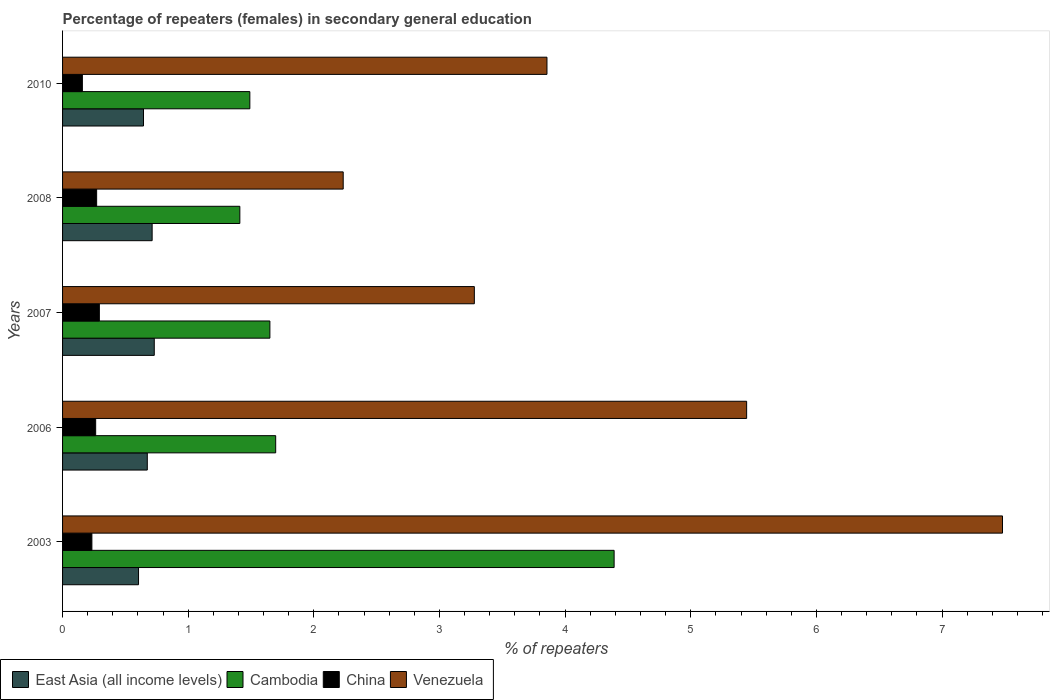How many groups of bars are there?
Offer a terse response. 5. How many bars are there on the 3rd tick from the bottom?
Your answer should be very brief. 4. What is the percentage of female repeaters in East Asia (all income levels) in 2007?
Keep it short and to the point. 0.73. Across all years, what is the maximum percentage of female repeaters in Cambodia?
Provide a short and direct response. 4.39. Across all years, what is the minimum percentage of female repeaters in China?
Give a very brief answer. 0.16. In which year was the percentage of female repeaters in China maximum?
Your answer should be compact. 2007. In which year was the percentage of female repeaters in East Asia (all income levels) minimum?
Provide a short and direct response. 2003. What is the total percentage of female repeaters in East Asia (all income levels) in the graph?
Ensure brevity in your answer.  3.37. What is the difference between the percentage of female repeaters in Cambodia in 2003 and that in 2006?
Provide a short and direct response. 2.69. What is the difference between the percentage of female repeaters in China in 2006 and the percentage of female repeaters in Cambodia in 2007?
Provide a short and direct response. -1.39. What is the average percentage of female repeaters in Venezuela per year?
Provide a short and direct response. 4.46. In the year 2007, what is the difference between the percentage of female repeaters in China and percentage of female repeaters in Cambodia?
Give a very brief answer. -1.36. In how many years, is the percentage of female repeaters in China greater than 7 %?
Keep it short and to the point. 0. What is the ratio of the percentage of female repeaters in Cambodia in 2003 to that in 2008?
Give a very brief answer. 3.11. Is the difference between the percentage of female repeaters in China in 2006 and 2007 greater than the difference between the percentage of female repeaters in Cambodia in 2006 and 2007?
Your response must be concise. No. What is the difference between the highest and the second highest percentage of female repeaters in East Asia (all income levels)?
Provide a succinct answer. 0.02. What is the difference between the highest and the lowest percentage of female repeaters in China?
Give a very brief answer. 0.14. In how many years, is the percentage of female repeaters in China greater than the average percentage of female repeaters in China taken over all years?
Ensure brevity in your answer.  3. Is the sum of the percentage of female repeaters in Venezuela in 2008 and 2010 greater than the maximum percentage of female repeaters in East Asia (all income levels) across all years?
Make the answer very short. Yes. What does the 1st bar from the top in 2003 represents?
Your answer should be very brief. Venezuela. What does the 1st bar from the bottom in 2007 represents?
Give a very brief answer. East Asia (all income levels). Is it the case that in every year, the sum of the percentage of female repeaters in Cambodia and percentage of female repeaters in Venezuela is greater than the percentage of female repeaters in East Asia (all income levels)?
Ensure brevity in your answer.  Yes. How many bars are there?
Your response must be concise. 20. Does the graph contain any zero values?
Offer a terse response. No. How many legend labels are there?
Keep it short and to the point. 4. How are the legend labels stacked?
Make the answer very short. Horizontal. What is the title of the graph?
Your answer should be compact. Percentage of repeaters (females) in secondary general education. What is the label or title of the X-axis?
Offer a very short reply. % of repeaters. What is the label or title of the Y-axis?
Keep it short and to the point. Years. What is the % of repeaters of East Asia (all income levels) in 2003?
Offer a terse response. 0.6. What is the % of repeaters of Cambodia in 2003?
Offer a very short reply. 4.39. What is the % of repeaters of China in 2003?
Give a very brief answer. 0.23. What is the % of repeaters of Venezuela in 2003?
Make the answer very short. 7.48. What is the % of repeaters of East Asia (all income levels) in 2006?
Your answer should be very brief. 0.67. What is the % of repeaters of Cambodia in 2006?
Your answer should be compact. 1.7. What is the % of repeaters in China in 2006?
Your answer should be very brief. 0.26. What is the % of repeaters of Venezuela in 2006?
Ensure brevity in your answer.  5.44. What is the % of repeaters in East Asia (all income levels) in 2007?
Keep it short and to the point. 0.73. What is the % of repeaters of Cambodia in 2007?
Your answer should be very brief. 1.65. What is the % of repeaters of China in 2007?
Ensure brevity in your answer.  0.29. What is the % of repeaters of Venezuela in 2007?
Make the answer very short. 3.28. What is the % of repeaters in East Asia (all income levels) in 2008?
Your response must be concise. 0.71. What is the % of repeaters of Cambodia in 2008?
Give a very brief answer. 1.41. What is the % of repeaters of China in 2008?
Make the answer very short. 0.27. What is the % of repeaters of Venezuela in 2008?
Your response must be concise. 2.23. What is the % of repeaters of East Asia (all income levels) in 2010?
Provide a succinct answer. 0.64. What is the % of repeaters of Cambodia in 2010?
Your answer should be very brief. 1.49. What is the % of repeaters in China in 2010?
Keep it short and to the point. 0.16. What is the % of repeaters of Venezuela in 2010?
Make the answer very short. 3.86. Across all years, what is the maximum % of repeaters in East Asia (all income levels)?
Your answer should be very brief. 0.73. Across all years, what is the maximum % of repeaters in Cambodia?
Your answer should be very brief. 4.39. Across all years, what is the maximum % of repeaters in China?
Keep it short and to the point. 0.29. Across all years, what is the maximum % of repeaters in Venezuela?
Give a very brief answer. 7.48. Across all years, what is the minimum % of repeaters in East Asia (all income levels)?
Make the answer very short. 0.6. Across all years, what is the minimum % of repeaters in Cambodia?
Ensure brevity in your answer.  1.41. Across all years, what is the minimum % of repeaters of China?
Offer a terse response. 0.16. Across all years, what is the minimum % of repeaters in Venezuela?
Keep it short and to the point. 2.23. What is the total % of repeaters in East Asia (all income levels) in the graph?
Offer a very short reply. 3.37. What is the total % of repeaters of Cambodia in the graph?
Provide a succinct answer. 10.64. What is the total % of repeaters of China in the graph?
Give a very brief answer. 1.22. What is the total % of repeaters in Venezuela in the graph?
Offer a very short reply. 22.29. What is the difference between the % of repeaters in East Asia (all income levels) in 2003 and that in 2006?
Ensure brevity in your answer.  -0.07. What is the difference between the % of repeaters of Cambodia in 2003 and that in 2006?
Offer a terse response. 2.69. What is the difference between the % of repeaters of China in 2003 and that in 2006?
Your answer should be compact. -0.03. What is the difference between the % of repeaters of Venezuela in 2003 and that in 2006?
Ensure brevity in your answer.  2.04. What is the difference between the % of repeaters of East Asia (all income levels) in 2003 and that in 2007?
Your response must be concise. -0.13. What is the difference between the % of repeaters in Cambodia in 2003 and that in 2007?
Ensure brevity in your answer.  2.74. What is the difference between the % of repeaters in China in 2003 and that in 2007?
Your answer should be very brief. -0.06. What is the difference between the % of repeaters in Venezuela in 2003 and that in 2007?
Your answer should be compact. 4.2. What is the difference between the % of repeaters in East Asia (all income levels) in 2003 and that in 2008?
Ensure brevity in your answer.  -0.11. What is the difference between the % of repeaters of Cambodia in 2003 and that in 2008?
Ensure brevity in your answer.  2.98. What is the difference between the % of repeaters of China in 2003 and that in 2008?
Keep it short and to the point. -0.04. What is the difference between the % of repeaters in Venezuela in 2003 and that in 2008?
Give a very brief answer. 5.25. What is the difference between the % of repeaters of East Asia (all income levels) in 2003 and that in 2010?
Ensure brevity in your answer.  -0.04. What is the difference between the % of repeaters in Cambodia in 2003 and that in 2010?
Give a very brief answer. 2.9. What is the difference between the % of repeaters of China in 2003 and that in 2010?
Keep it short and to the point. 0.08. What is the difference between the % of repeaters of Venezuela in 2003 and that in 2010?
Offer a terse response. 3.63. What is the difference between the % of repeaters in East Asia (all income levels) in 2006 and that in 2007?
Your response must be concise. -0.06. What is the difference between the % of repeaters of Cambodia in 2006 and that in 2007?
Your response must be concise. 0.05. What is the difference between the % of repeaters of China in 2006 and that in 2007?
Keep it short and to the point. -0.03. What is the difference between the % of repeaters of Venezuela in 2006 and that in 2007?
Your answer should be very brief. 2.17. What is the difference between the % of repeaters of East Asia (all income levels) in 2006 and that in 2008?
Make the answer very short. -0.04. What is the difference between the % of repeaters of Cambodia in 2006 and that in 2008?
Give a very brief answer. 0.29. What is the difference between the % of repeaters of China in 2006 and that in 2008?
Keep it short and to the point. -0.01. What is the difference between the % of repeaters of Venezuela in 2006 and that in 2008?
Ensure brevity in your answer.  3.21. What is the difference between the % of repeaters in East Asia (all income levels) in 2006 and that in 2010?
Offer a terse response. 0.03. What is the difference between the % of repeaters of Cambodia in 2006 and that in 2010?
Your response must be concise. 0.21. What is the difference between the % of repeaters of China in 2006 and that in 2010?
Offer a very short reply. 0.11. What is the difference between the % of repeaters in Venezuela in 2006 and that in 2010?
Your answer should be very brief. 1.59. What is the difference between the % of repeaters in East Asia (all income levels) in 2007 and that in 2008?
Give a very brief answer. 0.02. What is the difference between the % of repeaters in Cambodia in 2007 and that in 2008?
Make the answer very short. 0.24. What is the difference between the % of repeaters of China in 2007 and that in 2008?
Give a very brief answer. 0.02. What is the difference between the % of repeaters of Venezuela in 2007 and that in 2008?
Your response must be concise. 1.04. What is the difference between the % of repeaters of East Asia (all income levels) in 2007 and that in 2010?
Make the answer very short. 0.09. What is the difference between the % of repeaters of Cambodia in 2007 and that in 2010?
Give a very brief answer. 0.16. What is the difference between the % of repeaters of China in 2007 and that in 2010?
Ensure brevity in your answer.  0.14. What is the difference between the % of repeaters in Venezuela in 2007 and that in 2010?
Your answer should be very brief. -0.58. What is the difference between the % of repeaters in East Asia (all income levels) in 2008 and that in 2010?
Provide a short and direct response. 0.07. What is the difference between the % of repeaters in Cambodia in 2008 and that in 2010?
Keep it short and to the point. -0.08. What is the difference between the % of repeaters in China in 2008 and that in 2010?
Your response must be concise. 0.11. What is the difference between the % of repeaters of Venezuela in 2008 and that in 2010?
Ensure brevity in your answer.  -1.62. What is the difference between the % of repeaters in East Asia (all income levels) in 2003 and the % of repeaters in Cambodia in 2006?
Your response must be concise. -1.09. What is the difference between the % of repeaters in East Asia (all income levels) in 2003 and the % of repeaters in China in 2006?
Keep it short and to the point. 0.34. What is the difference between the % of repeaters of East Asia (all income levels) in 2003 and the % of repeaters of Venezuela in 2006?
Provide a short and direct response. -4.84. What is the difference between the % of repeaters in Cambodia in 2003 and the % of repeaters in China in 2006?
Offer a very short reply. 4.13. What is the difference between the % of repeaters of Cambodia in 2003 and the % of repeaters of Venezuela in 2006?
Your answer should be very brief. -1.05. What is the difference between the % of repeaters in China in 2003 and the % of repeaters in Venezuela in 2006?
Keep it short and to the point. -5.21. What is the difference between the % of repeaters in East Asia (all income levels) in 2003 and the % of repeaters in Cambodia in 2007?
Make the answer very short. -1.05. What is the difference between the % of repeaters in East Asia (all income levels) in 2003 and the % of repeaters in China in 2007?
Your answer should be very brief. 0.31. What is the difference between the % of repeaters of East Asia (all income levels) in 2003 and the % of repeaters of Venezuela in 2007?
Provide a short and direct response. -2.67. What is the difference between the % of repeaters in Cambodia in 2003 and the % of repeaters in China in 2007?
Give a very brief answer. 4.1. What is the difference between the % of repeaters in Cambodia in 2003 and the % of repeaters in Venezuela in 2007?
Provide a succinct answer. 1.11. What is the difference between the % of repeaters of China in 2003 and the % of repeaters of Venezuela in 2007?
Give a very brief answer. -3.04. What is the difference between the % of repeaters in East Asia (all income levels) in 2003 and the % of repeaters in Cambodia in 2008?
Make the answer very short. -0.81. What is the difference between the % of repeaters of East Asia (all income levels) in 2003 and the % of repeaters of China in 2008?
Provide a succinct answer. 0.33. What is the difference between the % of repeaters in East Asia (all income levels) in 2003 and the % of repeaters in Venezuela in 2008?
Make the answer very short. -1.63. What is the difference between the % of repeaters in Cambodia in 2003 and the % of repeaters in China in 2008?
Offer a terse response. 4.12. What is the difference between the % of repeaters in Cambodia in 2003 and the % of repeaters in Venezuela in 2008?
Keep it short and to the point. 2.16. What is the difference between the % of repeaters of China in 2003 and the % of repeaters of Venezuela in 2008?
Your response must be concise. -2. What is the difference between the % of repeaters of East Asia (all income levels) in 2003 and the % of repeaters of Cambodia in 2010?
Offer a very short reply. -0.89. What is the difference between the % of repeaters of East Asia (all income levels) in 2003 and the % of repeaters of China in 2010?
Give a very brief answer. 0.45. What is the difference between the % of repeaters in East Asia (all income levels) in 2003 and the % of repeaters in Venezuela in 2010?
Make the answer very short. -3.25. What is the difference between the % of repeaters of Cambodia in 2003 and the % of repeaters of China in 2010?
Provide a short and direct response. 4.23. What is the difference between the % of repeaters of Cambodia in 2003 and the % of repeaters of Venezuela in 2010?
Your answer should be compact. 0.53. What is the difference between the % of repeaters of China in 2003 and the % of repeaters of Venezuela in 2010?
Keep it short and to the point. -3.62. What is the difference between the % of repeaters of East Asia (all income levels) in 2006 and the % of repeaters of Cambodia in 2007?
Your answer should be very brief. -0.98. What is the difference between the % of repeaters of East Asia (all income levels) in 2006 and the % of repeaters of China in 2007?
Keep it short and to the point. 0.38. What is the difference between the % of repeaters of East Asia (all income levels) in 2006 and the % of repeaters of Venezuela in 2007?
Make the answer very short. -2.6. What is the difference between the % of repeaters of Cambodia in 2006 and the % of repeaters of China in 2007?
Keep it short and to the point. 1.4. What is the difference between the % of repeaters of Cambodia in 2006 and the % of repeaters of Venezuela in 2007?
Offer a terse response. -1.58. What is the difference between the % of repeaters in China in 2006 and the % of repeaters in Venezuela in 2007?
Provide a short and direct response. -3.01. What is the difference between the % of repeaters in East Asia (all income levels) in 2006 and the % of repeaters in Cambodia in 2008?
Your answer should be compact. -0.74. What is the difference between the % of repeaters in East Asia (all income levels) in 2006 and the % of repeaters in China in 2008?
Give a very brief answer. 0.4. What is the difference between the % of repeaters in East Asia (all income levels) in 2006 and the % of repeaters in Venezuela in 2008?
Your answer should be compact. -1.56. What is the difference between the % of repeaters in Cambodia in 2006 and the % of repeaters in China in 2008?
Your response must be concise. 1.43. What is the difference between the % of repeaters in Cambodia in 2006 and the % of repeaters in Venezuela in 2008?
Your response must be concise. -0.54. What is the difference between the % of repeaters in China in 2006 and the % of repeaters in Venezuela in 2008?
Give a very brief answer. -1.97. What is the difference between the % of repeaters in East Asia (all income levels) in 2006 and the % of repeaters in Cambodia in 2010?
Offer a very short reply. -0.82. What is the difference between the % of repeaters in East Asia (all income levels) in 2006 and the % of repeaters in China in 2010?
Offer a terse response. 0.52. What is the difference between the % of repeaters in East Asia (all income levels) in 2006 and the % of repeaters in Venezuela in 2010?
Keep it short and to the point. -3.18. What is the difference between the % of repeaters of Cambodia in 2006 and the % of repeaters of China in 2010?
Ensure brevity in your answer.  1.54. What is the difference between the % of repeaters of Cambodia in 2006 and the % of repeaters of Venezuela in 2010?
Provide a succinct answer. -2.16. What is the difference between the % of repeaters in China in 2006 and the % of repeaters in Venezuela in 2010?
Your answer should be very brief. -3.59. What is the difference between the % of repeaters of East Asia (all income levels) in 2007 and the % of repeaters of Cambodia in 2008?
Provide a short and direct response. -0.68. What is the difference between the % of repeaters of East Asia (all income levels) in 2007 and the % of repeaters of China in 2008?
Your answer should be compact. 0.46. What is the difference between the % of repeaters in East Asia (all income levels) in 2007 and the % of repeaters in Venezuela in 2008?
Your answer should be very brief. -1.5. What is the difference between the % of repeaters in Cambodia in 2007 and the % of repeaters in China in 2008?
Your response must be concise. 1.38. What is the difference between the % of repeaters in Cambodia in 2007 and the % of repeaters in Venezuela in 2008?
Provide a succinct answer. -0.58. What is the difference between the % of repeaters in China in 2007 and the % of repeaters in Venezuela in 2008?
Give a very brief answer. -1.94. What is the difference between the % of repeaters of East Asia (all income levels) in 2007 and the % of repeaters of Cambodia in 2010?
Your response must be concise. -0.76. What is the difference between the % of repeaters of East Asia (all income levels) in 2007 and the % of repeaters of China in 2010?
Your answer should be compact. 0.57. What is the difference between the % of repeaters of East Asia (all income levels) in 2007 and the % of repeaters of Venezuela in 2010?
Give a very brief answer. -3.13. What is the difference between the % of repeaters of Cambodia in 2007 and the % of repeaters of China in 2010?
Keep it short and to the point. 1.49. What is the difference between the % of repeaters in Cambodia in 2007 and the % of repeaters in Venezuela in 2010?
Your response must be concise. -2.21. What is the difference between the % of repeaters in China in 2007 and the % of repeaters in Venezuela in 2010?
Make the answer very short. -3.56. What is the difference between the % of repeaters of East Asia (all income levels) in 2008 and the % of repeaters of Cambodia in 2010?
Offer a terse response. -0.78. What is the difference between the % of repeaters in East Asia (all income levels) in 2008 and the % of repeaters in China in 2010?
Your answer should be compact. 0.56. What is the difference between the % of repeaters in East Asia (all income levels) in 2008 and the % of repeaters in Venezuela in 2010?
Offer a very short reply. -3.14. What is the difference between the % of repeaters in Cambodia in 2008 and the % of repeaters in China in 2010?
Offer a very short reply. 1.25. What is the difference between the % of repeaters in Cambodia in 2008 and the % of repeaters in Venezuela in 2010?
Ensure brevity in your answer.  -2.44. What is the difference between the % of repeaters of China in 2008 and the % of repeaters of Venezuela in 2010?
Your answer should be compact. -3.58. What is the average % of repeaters in East Asia (all income levels) per year?
Keep it short and to the point. 0.67. What is the average % of repeaters of Cambodia per year?
Your answer should be compact. 2.13. What is the average % of repeaters of China per year?
Ensure brevity in your answer.  0.24. What is the average % of repeaters of Venezuela per year?
Make the answer very short. 4.46. In the year 2003, what is the difference between the % of repeaters in East Asia (all income levels) and % of repeaters in Cambodia?
Your answer should be compact. -3.79. In the year 2003, what is the difference between the % of repeaters of East Asia (all income levels) and % of repeaters of China?
Keep it short and to the point. 0.37. In the year 2003, what is the difference between the % of repeaters in East Asia (all income levels) and % of repeaters in Venezuela?
Your answer should be compact. -6.88. In the year 2003, what is the difference between the % of repeaters of Cambodia and % of repeaters of China?
Ensure brevity in your answer.  4.16. In the year 2003, what is the difference between the % of repeaters of Cambodia and % of repeaters of Venezuela?
Keep it short and to the point. -3.09. In the year 2003, what is the difference between the % of repeaters in China and % of repeaters in Venezuela?
Keep it short and to the point. -7.25. In the year 2006, what is the difference between the % of repeaters of East Asia (all income levels) and % of repeaters of Cambodia?
Offer a terse response. -1.02. In the year 2006, what is the difference between the % of repeaters in East Asia (all income levels) and % of repeaters in China?
Your answer should be very brief. 0.41. In the year 2006, what is the difference between the % of repeaters in East Asia (all income levels) and % of repeaters in Venezuela?
Keep it short and to the point. -4.77. In the year 2006, what is the difference between the % of repeaters of Cambodia and % of repeaters of China?
Offer a very short reply. 1.43. In the year 2006, what is the difference between the % of repeaters in Cambodia and % of repeaters in Venezuela?
Give a very brief answer. -3.75. In the year 2006, what is the difference between the % of repeaters in China and % of repeaters in Venezuela?
Your answer should be compact. -5.18. In the year 2007, what is the difference between the % of repeaters of East Asia (all income levels) and % of repeaters of Cambodia?
Offer a very short reply. -0.92. In the year 2007, what is the difference between the % of repeaters of East Asia (all income levels) and % of repeaters of China?
Provide a succinct answer. 0.44. In the year 2007, what is the difference between the % of repeaters in East Asia (all income levels) and % of repeaters in Venezuela?
Offer a terse response. -2.55. In the year 2007, what is the difference between the % of repeaters in Cambodia and % of repeaters in China?
Give a very brief answer. 1.36. In the year 2007, what is the difference between the % of repeaters in Cambodia and % of repeaters in Venezuela?
Give a very brief answer. -1.63. In the year 2007, what is the difference between the % of repeaters of China and % of repeaters of Venezuela?
Give a very brief answer. -2.98. In the year 2008, what is the difference between the % of repeaters in East Asia (all income levels) and % of repeaters in Cambodia?
Provide a succinct answer. -0.7. In the year 2008, what is the difference between the % of repeaters of East Asia (all income levels) and % of repeaters of China?
Offer a very short reply. 0.44. In the year 2008, what is the difference between the % of repeaters of East Asia (all income levels) and % of repeaters of Venezuela?
Offer a terse response. -1.52. In the year 2008, what is the difference between the % of repeaters in Cambodia and % of repeaters in China?
Offer a very short reply. 1.14. In the year 2008, what is the difference between the % of repeaters of Cambodia and % of repeaters of Venezuela?
Offer a terse response. -0.82. In the year 2008, what is the difference between the % of repeaters of China and % of repeaters of Venezuela?
Keep it short and to the point. -1.96. In the year 2010, what is the difference between the % of repeaters in East Asia (all income levels) and % of repeaters in Cambodia?
Your response must be concise. -0.85. In the year 2010, what is the difference between the % of repeaters of East Asia (all income levels) and % of repeaters of China?
Your answer should be compact. 0.49. In the year 2010, what is the difference between the % of repeaters of East Asia (all income levels) and % of repeaters of Venezuela?
Your response must be concise. -3.21. In the year 2010, what is the difference between the % of repeaters of Cambodia and % of repeaters of China?
Make the answer very short. 1.33. In the year 2010, what is the difference between the % of repeaters of Cambodia and % of repeaters of Venezuela?
Make the answer very short. -2.36. In the year 2010, what is the difference between the % of repeaters of China and % of repeaters of Venezuela?
Provide a short and direct response. -3.7. What is the ratio of the % of repeaters in East Asia (all income levels) in 2003 to that in 2006?
Offer a terse response. 0.9. What is the ratio of the % of repeaters in Cambodia in 2003 to that in 2006?
Ensure brevity in your answer.  2.59. What is the ratio of the % of repeaters of China in 2003 to that in 2006?
Keep it short and to the point. 0.89. What is the ratio of the % of repeaters of Venezuela in 2003 to that in 2006?
Your answer should be very brief. 1.37. What is the ratio of the % of repeaters of East Asia (all income levels) in 2003 to that in 2007?
Offer a very short reply. 0.83. What is the ratio of the % of repeaters in Cambodia in 2003 to that in 2007?
Your answer should be compact. 2.66. What is the ratio of the % of repeaters of China in 2003 to that in 2007?
Keep it short and to the point. 0.8. What is the ratio of the % of repeaters of Venezuela in 2003 to that in 2007?
Your answer should be very brief. 2.28. What is the ratio of the % of repeaters in East Asia (all income levels) in 2003 to that in 2008?
Offer a terse response. 0.85. What is the ratio of the % of repeaters in Cambodia in 2003 to that in 2008?
Provide a succinct answer. 3.11. What is the ratio of the % of repeaters in China in 2003 to that in 2008?
Ensure brevity in your answer.  0.86. What is the ratio of the % of repeaters in Venezuela in 2003 to that in 2008?
Give a very brief answer. 3.35. What is the ratio of the % of repeaters of East Asia (all income levels) in 2003 to that in 2010?
Provide a succinct answer. 0.94. What is the ratio of the % of repeaters of Cambodia in 2003 to that in 2010?
Offer a very short reply. 2.94. What is the ratio of the % of repeaters of China in 2003 to that in 2010?
Provide a short and direct response. 1.48. What is the ratio of the % of repeaters in Venezuela in 2003 to that in 2010?
Make the answer very short. 1.94. What is the ratio of the % of repeaters of East Asia (all income levels) in 2006 to that in 2007?
Your response must be concise. 0.92. What is the ratio of the % of repeaters in Cambodia in 2006 to that in 2007?
Your response must be concise. 1.03. What is the ratio of the % of repeaters of China in 2006 to that in 2007?
Offer a very short reply. 0.9. What is the ratio of the % of repeaters of Venezuela in 2006 to that in 2007?
Offer a very short reply. 1.66. What is the ratio of the % of repeaters of East Asia (all income levels) in 2006 to that in 2008?
Your response must be concise. 0.95. What is the ratio of the % of repeaters of Cambodia in 2006 to that in 2008?
Make the answer very short. 1.2. What is the ratio of the % of repeaters in China in 2006 to that in 2008?
Provide a succinct answer. 0.97. What is the ratio of the % of repeaters of Venezuela in 2006 to that in 2008?
Your response must be concise. 2.44. What is the ratio of the % of repeaters in East Asia (all income levels) in 2006 to that in 2010?
Ensure brevity in your answer.  1.05. What is the ratio of the % of repeaters in Cambodia in 2006 to that in 2010?
Your answer should be compact. 1.14. What is the ratio of the % of repeaters of China in 2006 to that in 2010?
Provide a succinct answer. 1.67. What is the ratio of the % of repeaters in Venezuela in 2006 to that in 2010?
Give a very brief answer. 1.41. What is the ratio of the % of repeaters in East Asia (all income levels) in 2007 to that in 2008?
Make the answer very short. 1.02. What is the ratio of the % of repeaters of Cambodia in 2007 to that in 2008?
Your answer should be compact. 1.17. What is the ratio of the % of repeaters of China in 2007 to that in 2008?
Your answer should be very brief. 1.08. What is the ratio of the % of repeaters of Venezuela in 2007 to that in 2008?
Give a very brief answer. 1.47. What is the ratio of the % of repeaters of East Asia (all income levels) in 2007 to that in 2010?
Keep it short and to the point. 1.13. What is the ratio of the % of repeaters of Cambodia in 2007 to that in 2010?
Offer a terse response. 1.11. What is the ratio of the % of repeaters in China in 2007 to that in 2010?
Provide a short and direct response. 1.86. What is the ratio of the % of repeaters in Venezuela in 2007 to that in 2010?
Make the answer very short. 0.85. What is the ratio of the % of repeaters of East Asia (all income levels) in 2008 to that in 2010?
Ensure brevity in your answer.  1.11. What is the ratio of the % of repeaters of Cambodia in 2008 to that in 2010?
Ensure brevity in your answer.  0.95. What is the ratio of the % of repeaters of China in 2008 to that in 2010?
Your answer should be compact. 1.72. What is the ratio of the % of repeaters of Venezuela in 2008 to that in 2010?
Offer a very short reply. 0.58. What is the difference between the highest and the second highest % of repeaters in East Asia (all income levels)?
Keep it short and to the point. 0.02. What is the difference between the highest and the second highest % of repeaters of Cambodia?
Your response must be concise. 2.69. What is the difference between the highest and the second highest % of repeaters of China?
Your answer should be very brief. 0.02. What is the difference between the highest and the second highest % of repeaters of Venezuela?
Keep it short and to the point. 2.04. What is the difference between the highest and the lowest % of repeaters in East Asia (all income levels)?
Your response must be concise. 0.13. What is the difference between the highest and the lowest % of repeaters of Cambodia?
Your answer should be very brief. 2.98. What is the difference between the highest and the lowest % of repeaters of China?
Offer a terse response. 0.14. What is the difference between the highest and the lowest % of repeaters of Venezuela?
Make the answer very short. 5.25. 